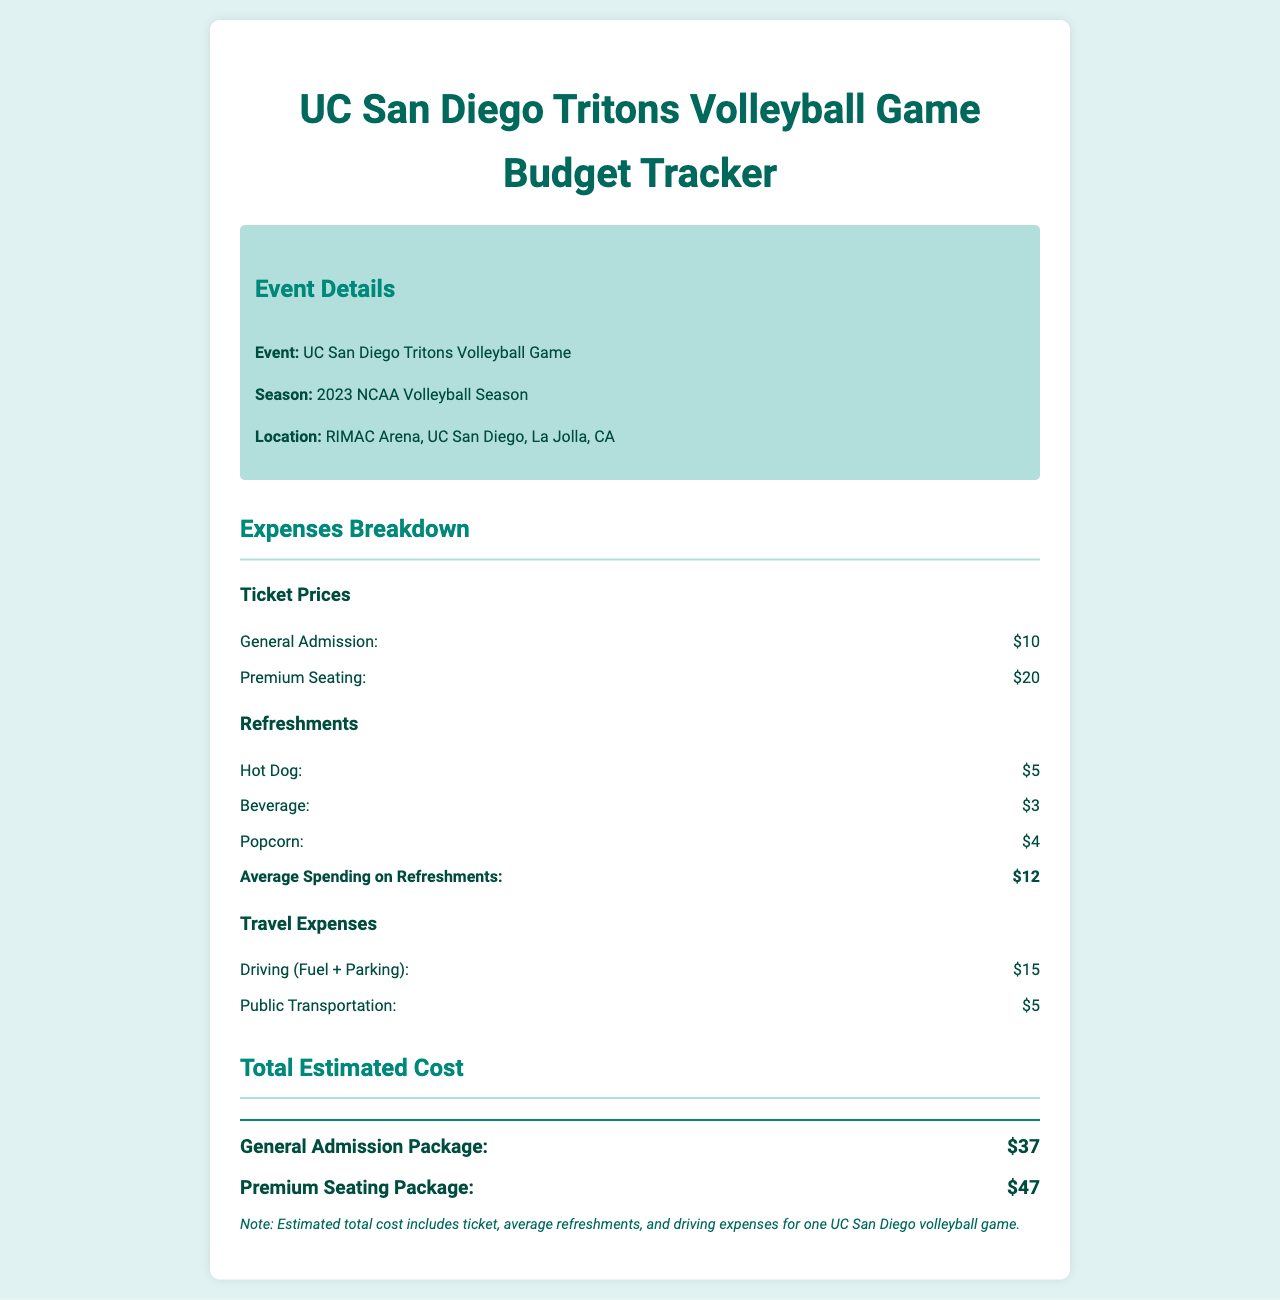What is the location of the game? The location of the game is specified in the document as "RIMAC Arena, UC San Diego, La Jolla, CA."
Answer: RIMAC Arena, UC San Diego, La Jolla, CA What is the cost of premium seating? The document lists the price for premium seating as $20.
Answer: $20 What is the average spending on refreshments? The document states that the average spending on refreshments is $12.
Answer: $12 How much does driving (fuel + parking) cost? The document specifies the cost of driving (fuel + parking) as $15.
Answer: $15 What is the total estimated cost for the general admission package? The total estimated cost for the general admission package is given as $37 in the document.
Answer: $37 What type of event is this document about? The document describes the event as a "UC San Diego Tritons Volleyball Game."
Answer: UC San Diego Tritons Volleyball Game How much is a hot dog? The cost of a hot dog is mentioned as $5 in the document.
Answer: $5 What is the season mentioned in the document? The document refers to the season as the "2023 NCAA Volleyball Season."
Answer: 2023 NCAA Volleyball Season 